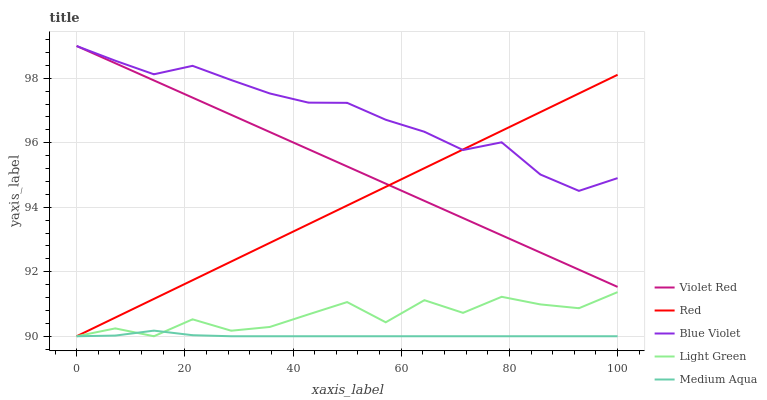Does Medium Aqua have the minimum area under the curve?
Answer yes or no. Yes. Does Blue Violet have the maximum area under the curve?
Answer yes or no. Yes. Does Light Green have the minimum area under the curve?
Answer yes or no. No. Does Light Green have the maximum area under the curve?
Answer yes or no. No. Is Red the smoothest?
Answer yes or no. Yes. Is Light Green the roughest?
Answer yes or no. Yes. Is Medium Aqua the smoothest?
Answer yes or no. No. Is Medium Aqua the roughest?
Answer yes or no. No. Does Blue Violet have the lowest value?
Answer yes or no. No. Does Light Green have the highest value?
Answer yes or no. No. Is Light Green less than Violet Red?
Answer yes or no. Yes. Is Blue Violet greater than Medium Aqua?
Answer yes or no. Yes. Does Light Green intersect Violet Red?
Answer yes or no. No. 